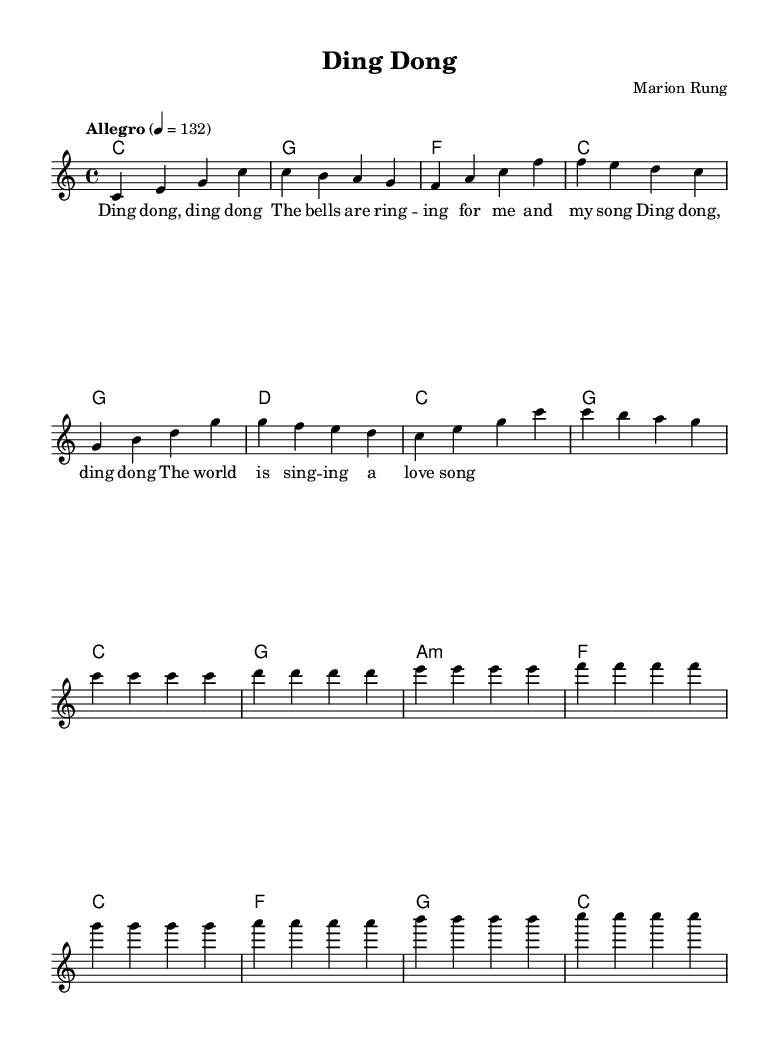What is the key signature of this music? The key signature is C major, which has no sharps or flats.
Answer: C major What is the time signature of this music? The time signature indicates how many beats are in each measure; in this case, it shows 4 beats per measure.
Answer: 4/4 What is the tempo marking of this music? The tempo marking "Allegro" indicates a fast and lively pace, specified by a metronome marking of 132 beats per minute.
Answer: Allegro 4 = 132 How many measures are there in the melody? By counting the measures in the melody part, we find a total of 14 measures present.
Answer: 14 Which chord appears most frequently? By analyzing the chord progression, the C major chord appears consistently in multiple measures, making it the most frequent.
Answer: C What is the text of the first line of lyrics? The first line of lyrics reads "Ding dong, ding dong," which corresponds to the melody in the first measures.
Answer: Ding dong, ding dong What is the structure of the lyrics in this piece? The lyrics follow a repetitive and catchy structure, emphasizing the phrase "Ding dong," and celebrating a cheerful sentiment throughout the song.
Answer: Verse 